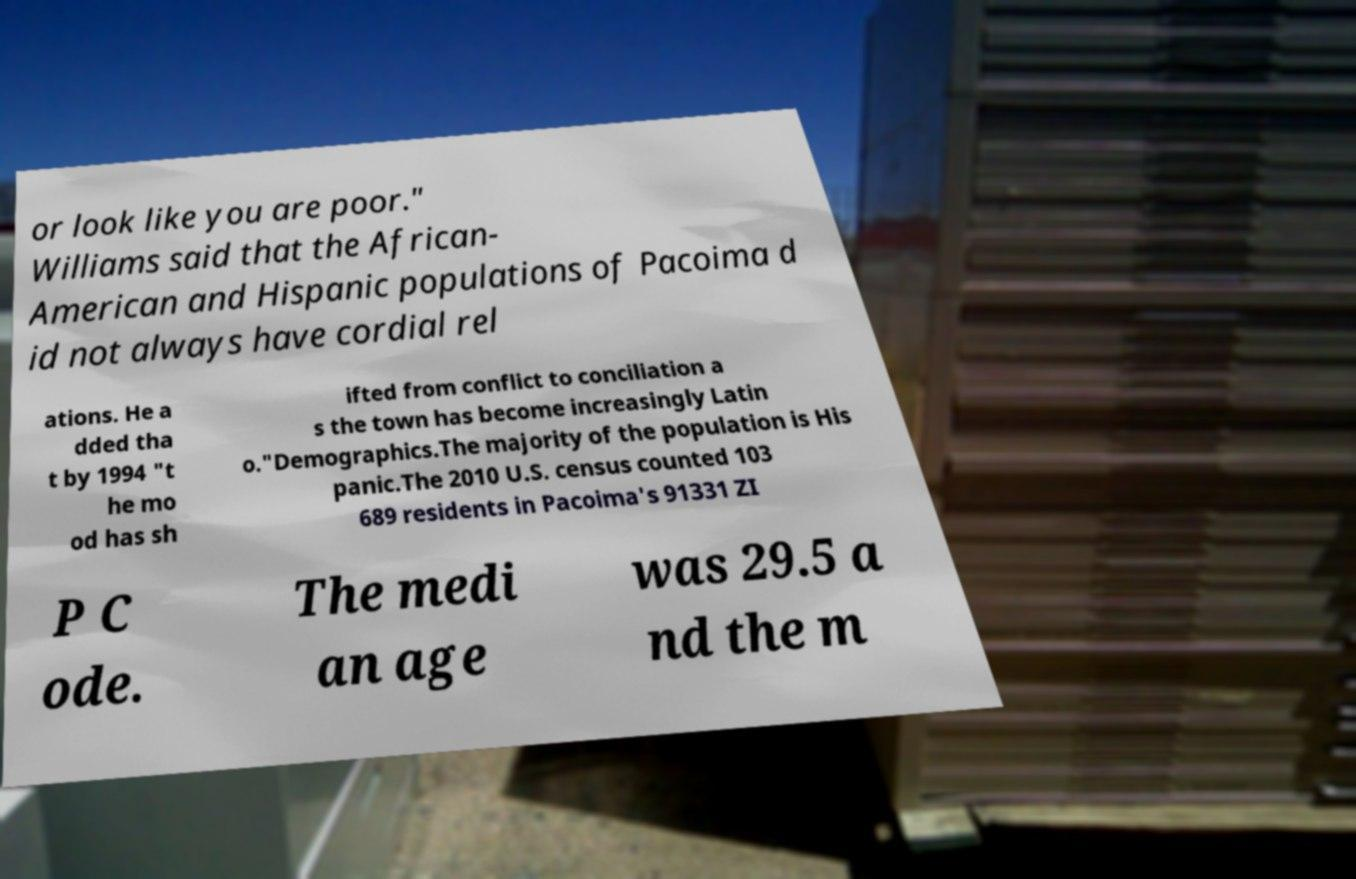Could you assist in decoding the text presented in this image and type it out clearly? or look like you are poor." Williams said that the African- American and Hispanic populations of Pacoima d id not always have cordial rel ations. He a dded tha t by 1994 "t he mo od has sh ifted from conflict to conciliation a s the town has become increasingly Latin o."Demographics.The majority of the population is His panic.The 2010 U.S. census counted 103 689 residents in Pacoima's 91331 ZI P C ode. The medi an age was 29.5 a nd the m 